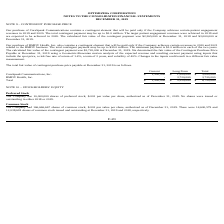According to Optimizerx Corporation's financial document, How much is the total contingent payment for the purchase of CareSpeak Communications? According to the financial document, up to $3.0 million. The relevant text states: "019 and 2020. The total contingent payment may be up to $3.0 million. The target patient engagement revenues were achieved in 2019 and are expected to be achieved in 20..." Also, How did the company determine the fair value of the Contingent Purchase Price Payable on December 31, 2019? using a Geometric-Brownian motion analysis of the expected revenue and resulting earnout payment using inputs that include the spot price, a risk free rate of return of 1.4%, a term of 2 years, and volatility of 40%. The document states: "ingent Purchase Price Payable at December 31, 2019 using a Geometric-Brownian motion analysis of the expected revenue and resulting earnout payment us..." Also, What is the total current fair value of contingent purchase price payable on December 31, 2019? According to the financial document, $1,500,000. The relevant text states: "CareSpeak Communications, Inc. $ 1,500,000 $ 1,500,000 $ 3,000,000..." Also, can you calculate: What is the proportion of total long-term fair value of contingent purchase price payable over total fair value of contingent purchase price payable? Based on the calculation: 5,220,000/6,720,000 , the result is 0.78. This is based on the information: "Total $ 1,500,000 $ 5,220,000 $ 6,720,000 Total $ 1,500,000 $ 5,220,000 $ 6,720,000..." The key data points involved are: 5,220,000, 6,720,000. Also, can you calculate: What is the ratio of total fair value of the contingent payment in 2018 to 2019? Based on the calculation: 2,365,000/3,000,000 , the result is 0.79. This is based on the information: "culated fair value of the contingent payment was $2,365,000 at December 31, 2018 and $3,000,000 at December 31, 2019. Our purchase of RMDY Health, Inc. also co payment was $2,365,000 at December 31, 2..." The key data points involved are: 2,365,000, 3,000,000. Also, can you calculate: What is the percentage change in the total fair value of the contingent payment in 2019 compared to 2018? To answer this question, I need to perform calculations using the financial data. The calculation is: (3,000,000-2,365,000)/2,365,000 , which equals 26.85 (percentage). This is based on the information: "culated fair value of the contingent payment was $2,365,000 at December 31, 2018 and $3,000,000 at December 31, 2019. Our purchase of RMDY Health, Inc. also co payment was $2,365,000 at December 31, 2..." The key data points involved are: 2,365,000, 3,000,000. 